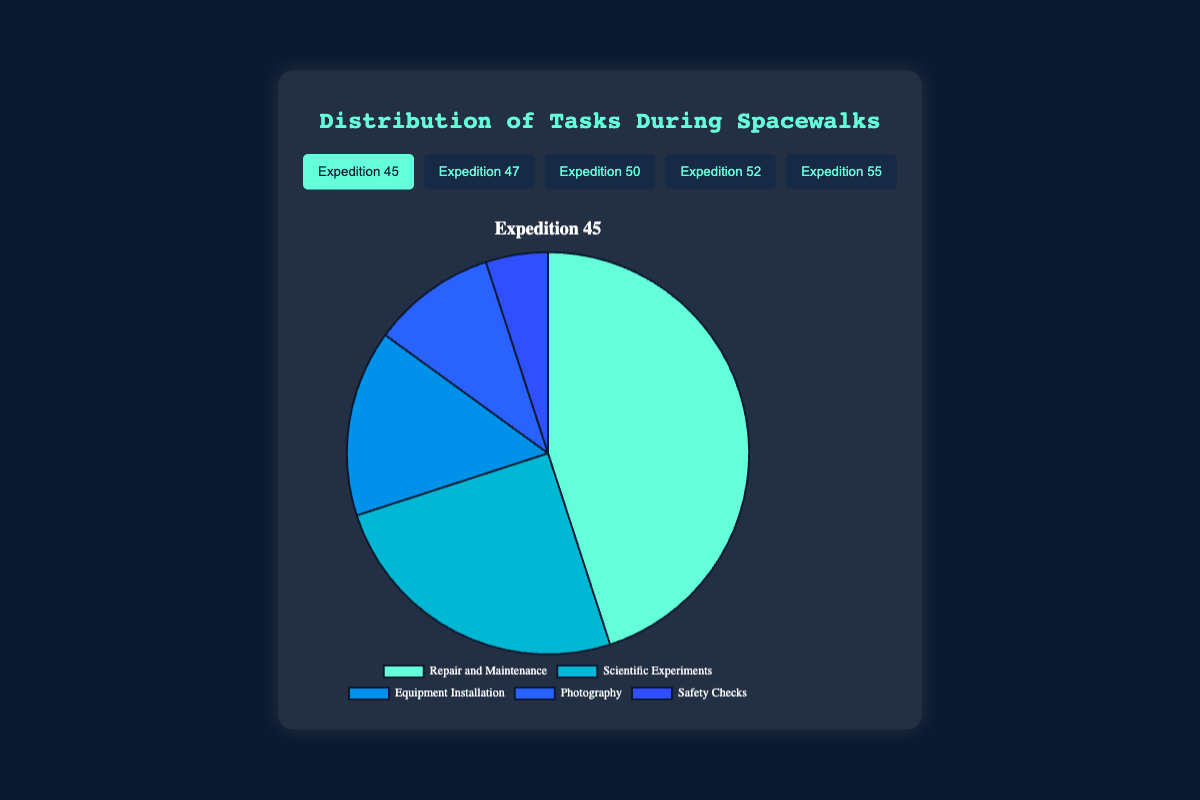Which task had the highest percentage during Expedition 45? From the data on Expedition 45, Repair and Maintenance had 45%, which is the highest compared to other tasks.
Answer: Repair and Maintenance During Expedition 47, did Equipment Installation or Scientific Experiments occupy a bigger percentage? Comparing the data for Expedition 47, Equipment Installation was 20% and Scientific Experiments were 20% as well, so they are equal.
Answer: Equal Summing up the percentages of Repair and Maintenance across all expeditions, what is the total percentage? Adding the percentages of Repair and Maintenance for all missions: 45% + 50% + 40% + 35% + 55% = 225%.
Answer: 225% In which expedition was the percentage of Photography the lowest? Comparing all expeditions, Photography was 5% in Expeditions 47, 50, and 55. However, Expedition 47 appears first in the list.
Answer: Expedition 47 What is the average percentage of Scientific Experiments across all missions? To find the average, sum the percentages: 25% + 20% + 30% + 25% + 20% = 120%, then divide by the number of missions: 120% / 5 = 24%.
Answer: 24% Which task generally occupies the smallest percentage across all missions? Observing the data, Safety Checks had the smallest percentage in each mission (5%).
Answer: Safety Checks Which expedition had the highest overall percentage dedicated to Equipment Installation? Reviewing the data, the percentages for Equipment Installation: Expedition 45 - 15%, Expedition 47 - 20%, Expedition 50 - 20%, Expedition 52 - 25%, Expedition 55 - 15%. The highest is 25% during Expedition 52.
Answer: Expedition 52 Looking at Expedition 50, how much greater is the percentage of Scientific Experiments compared to Photography? In Expedition 50, Scientific Experiments are at 30% and Photography is at 5%. The difference is 30% - 5% = 25%.
Answer: 25% In Expedition 55, is the combined percentage of Photography and Safety Checks greater than Equipment Installation? In Expedition 55, Photography is 5% and Safety Checks is 5%. Summing them: 5% + 5% = 10%. Comparing to Equipment Installation which is 15%, 10% < 15%.
Answer: No 